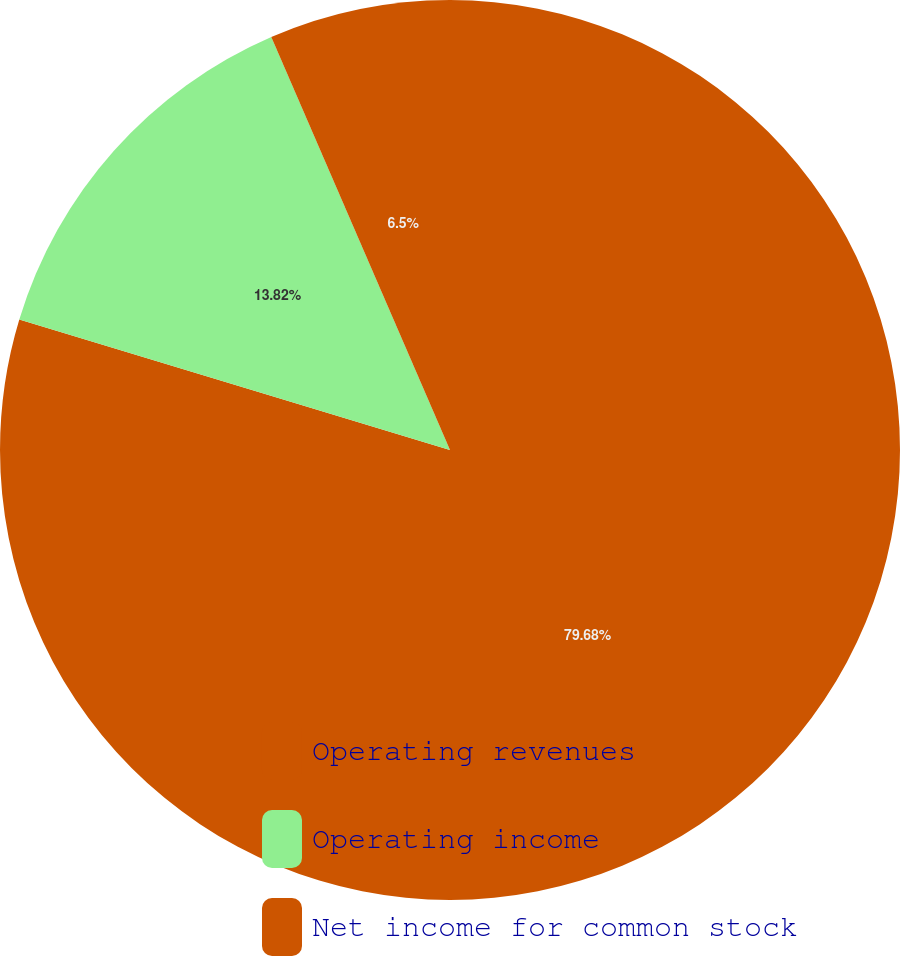<chart> <loc_0><loc_0><loc_500><loc_500><pie_chart><fcel>Operating revenues<fcel>Operating income<fcel>Net income for common stock<nl><fcel>79.68%<fcel>13.82%<fcel>6.5%<nl></chart> 